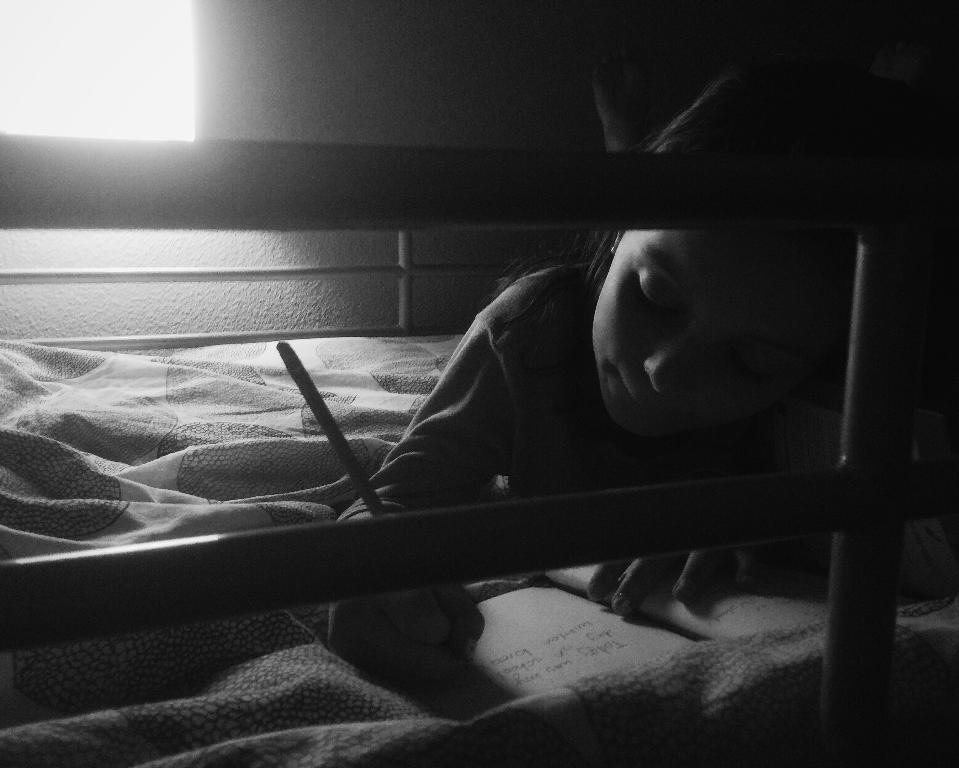What is the person on the bed doing? The person is laying on the bed and holding a book. What activity is the person engaged in while holding the book? The person is writing with a pen. What can be seen in the background of the image? There is a wall and a light in the background. Is there a maid in the image helping the person write with the pen? No, there is no maid present in the image. What type of heart is visible in the image? There is no heart present in the image. 